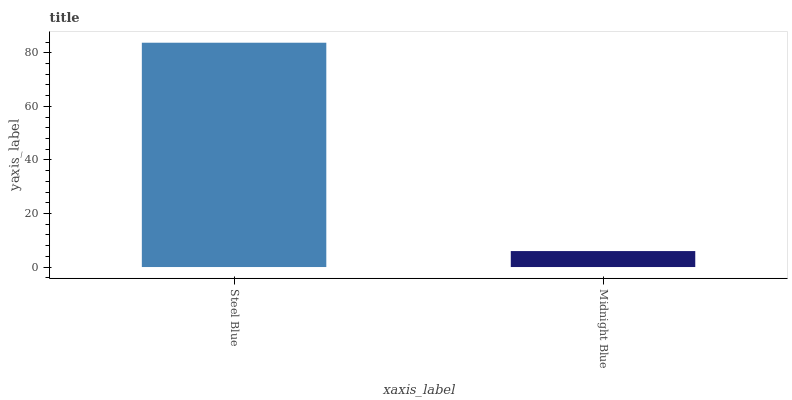Is Midnight Blue the minimum?
Answer yes or no. Yes. Is Steel Blue the maximum?
Answer yes or no. Yes. Is Midnight Blue the maximum?
Answer yes or no. No. Is Steel Blue greater than Midnight Blue?
Answer yes or no. Yes. Is Midnight Blue less than Steel Blue?
Answer yes or no. Yes. Is Midnight Blue greater than Steel Blue?
Answer yes or no. No. Is Steel Blue less than Midnight Blue?
Answer yes or no. No. Is Steel Blue the high median?
Answer yes or no. Yes. Is Midnight Blue the low median?
Answer yes or no. Yes. Is Midnight Blue the high median?
Answer yes or no. No. Is Steel Blue the low median?
Answer yes or no. No. 